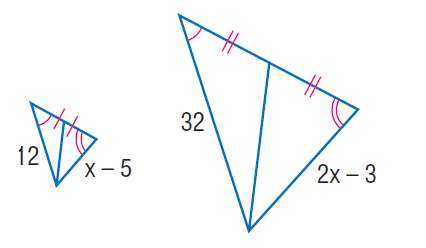Answer the mathemtical geometry problem and directly provide the correct option letter.
Question: Find x.
Choices: A: 12 B: 15.5 C: 16 D: 19 B 